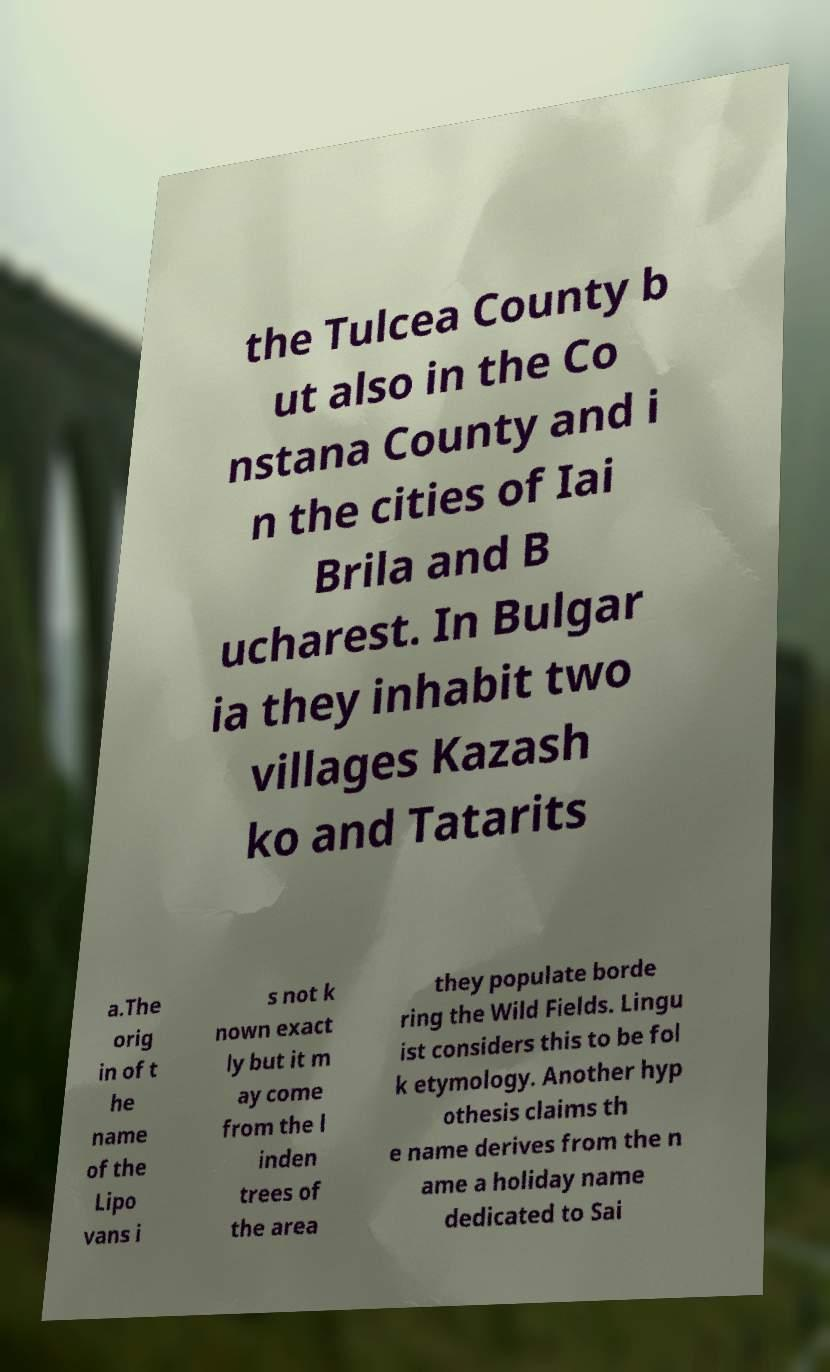For documentation purposes, I need the text within this image transcribed. Could you provide that? the Tulcea County b ut also in the Co nstana County and i n the cities of Iai Brila and B ucharest. In Bulgar ia they inhabit two villages Kazash ko and Tatarits a.The orig in of t he name of the Lipo vans i s not k nown exact ly but it m ay come from the l inden trees of the area they populate borde ring the Wild Fields. Lingu ist considers this to be fol k etymology. Another hyp othesis claims th e name derives from the n ame a holiday name dedicated to Sai 